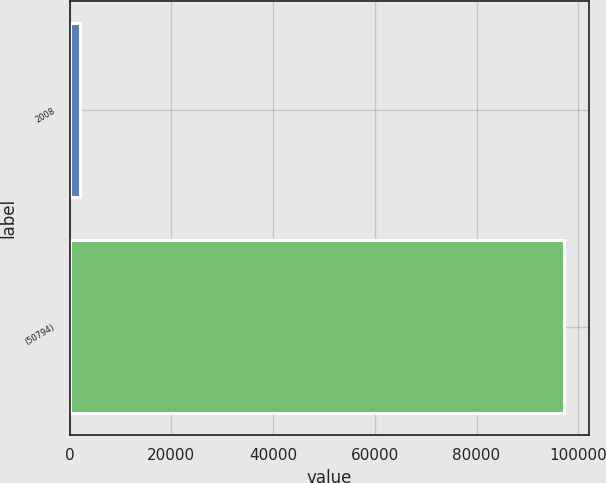Convert chart. <chart><loc_0><loc_0><loc_500><loc_500><bar_chart><fcel>2008<fcel>(50794)<nl><fcel>2006<fcel>97277<nl></chart> 